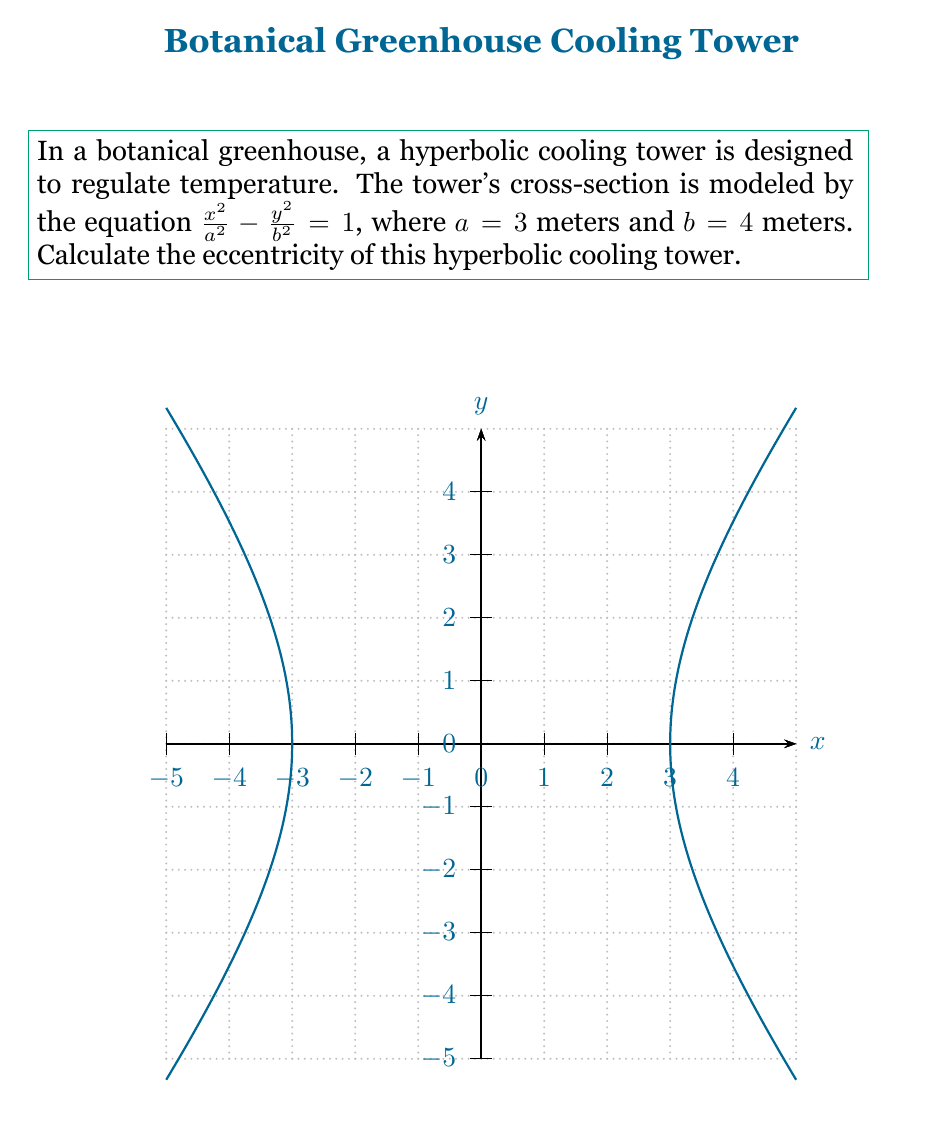Can you answer this question? To calculate the eccentricity of a hyperbola, we follow these steps:

1) The eccentricity ($e$) of a hyperbola is given by the formula:

   $$e = \sqrt{1 + \frac{b^2}{a^2}}$$

   where $a$ is the distance from the center to the vertex, and $b$ is the distance from the center to the co-vertex.

2) We are given that $a = 3$ meters and $b = 4$ meters.

3) Let's substitute these values into the formula:

   $$e = \sqrt{1 + \frac{4^2}{3^2}}$$

4) Simplify the fraction inside the square root:

   $$e = \sqrt{1 + \frac{16}{9}}$$

5) Add the fractions under the square root:

   $$e = \sqrt{\frac{9}{9} + \frac{16}{9}} = \sqrt{\frac{25}{9}}$$

6) Simplify the square root:

   $$e = \frac{5}{3}$$

Thus, the eccentricity of the hyperbolic cooling tower is $\frac{5}{3}$.
Answer: $\frac{5}{3}$ 